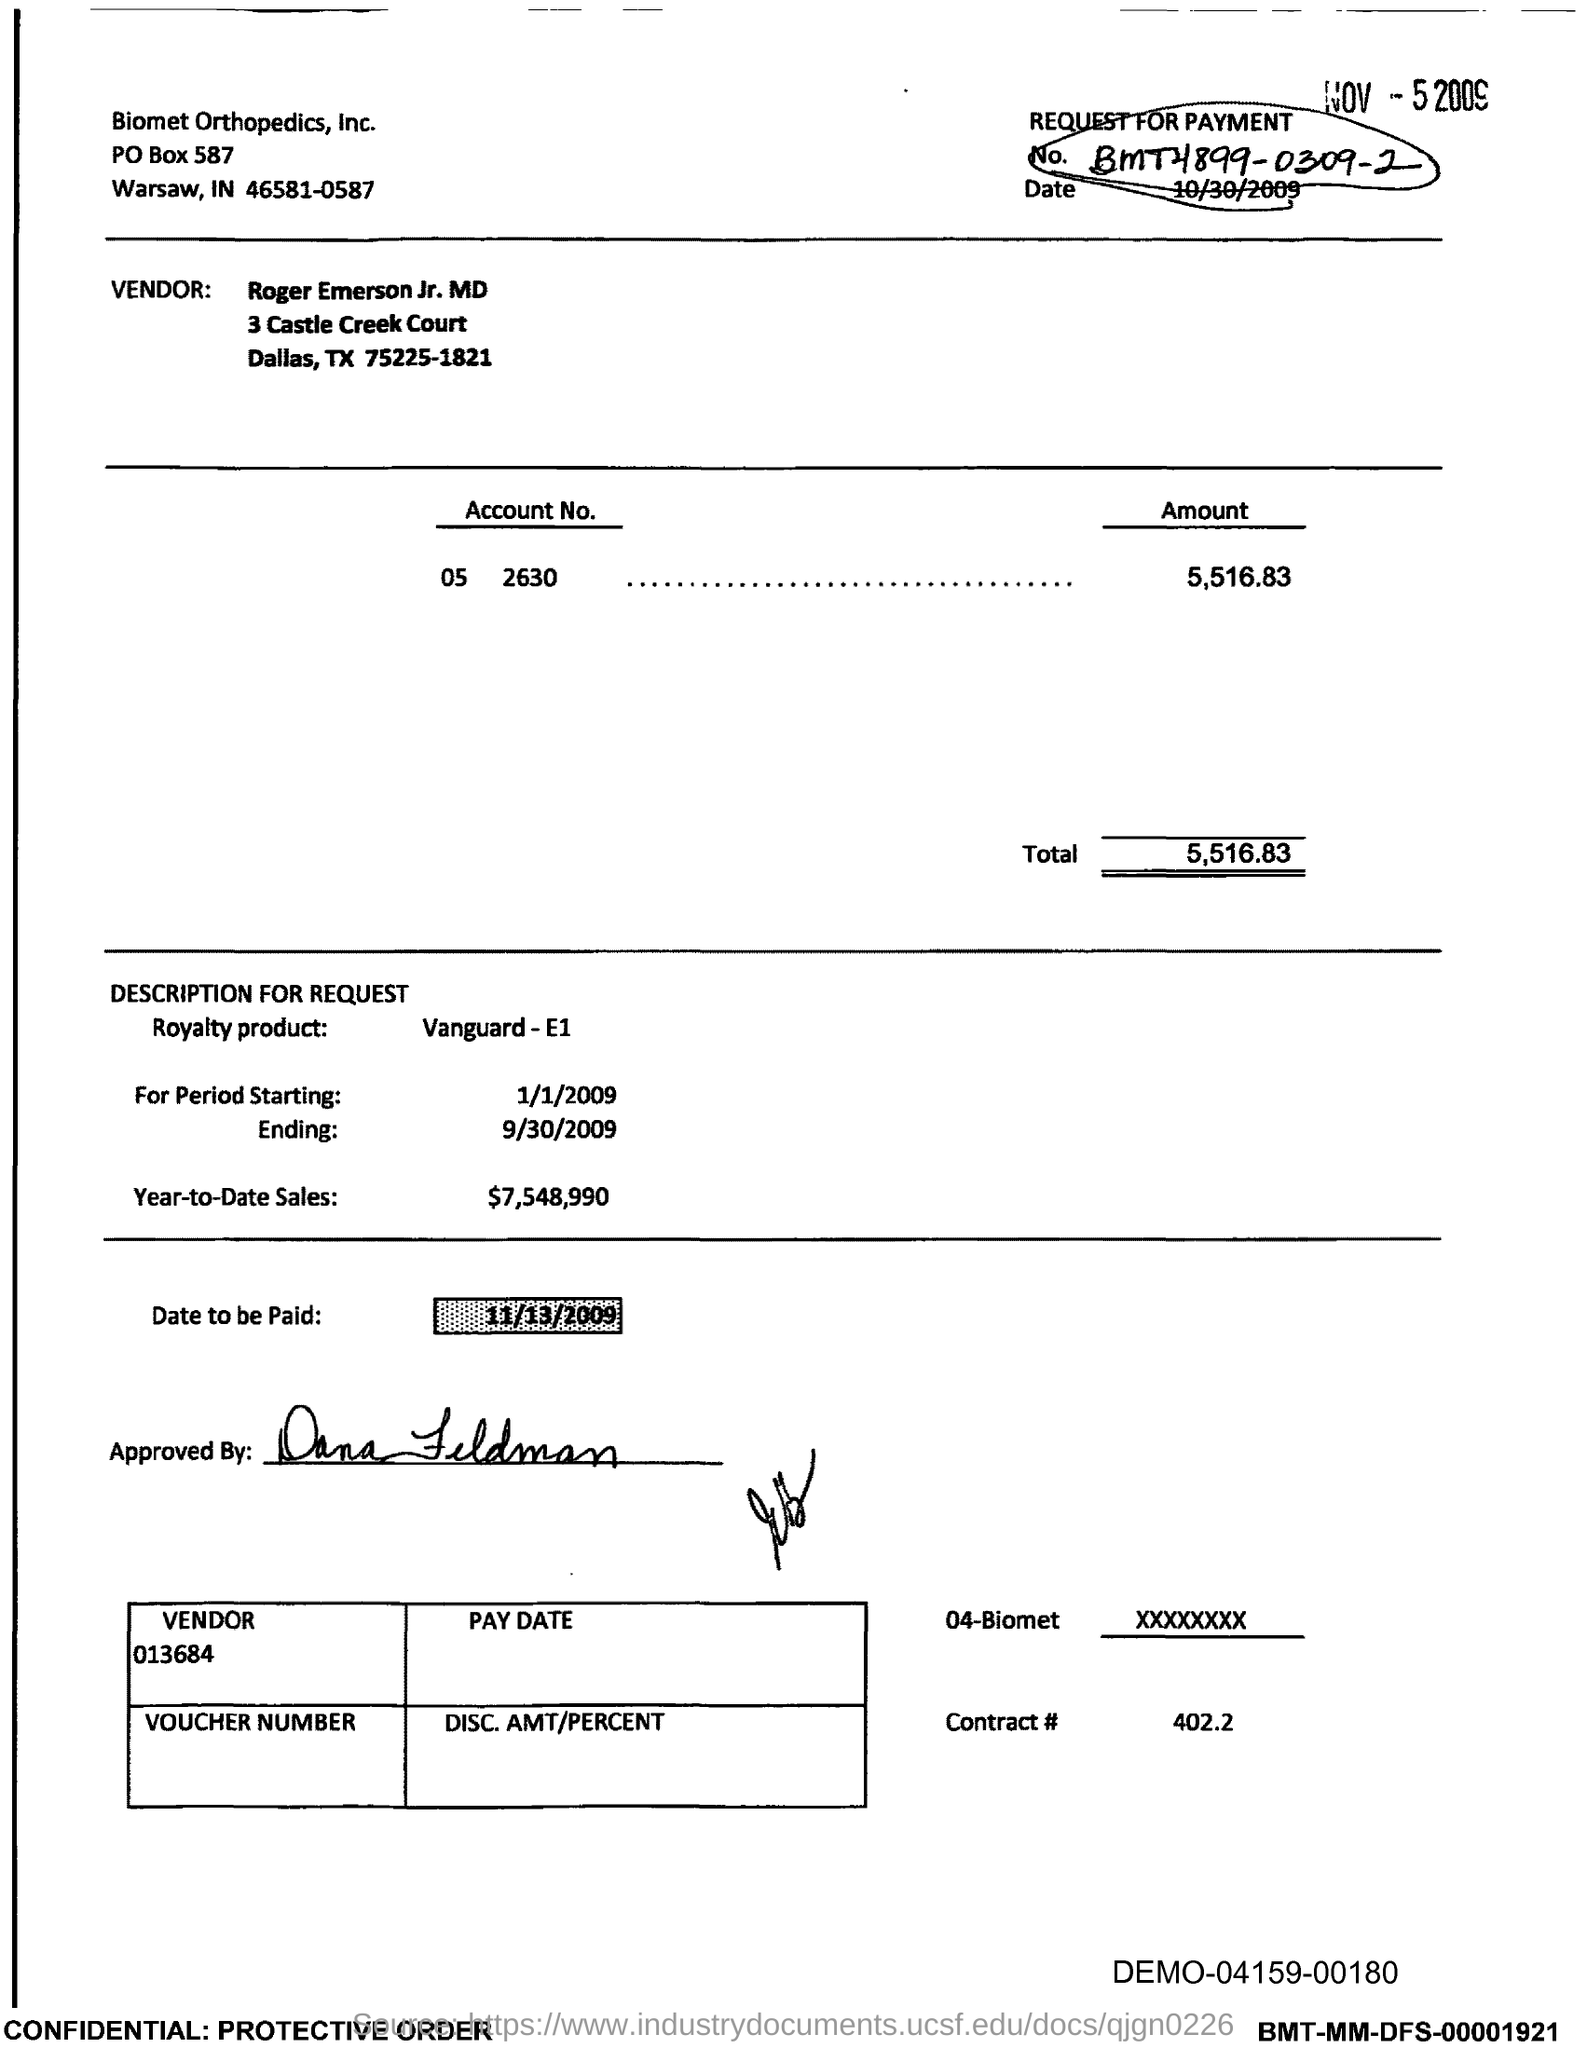What is the account no?
Give a very brief answer. 05 2630. What is the amount mentioned?
Provide a succinct answer. 5,516.83. What is the starting period?
Provide a short and direct response. 1/1/2009. What is the ending period mentioned?
Your response must be concise. 9/30/2009. What is the Year-to-Date Sales?
Ensure brevity in your answer.  $7,548,990. What is the date to be paid?
Ensure brevity in your answer.  11/13/2009. Who approved the bill?
Offer a terse response. Dana Feldman. What is the total amount specified?
Ensure brevity in your answer.  5,516.83. 